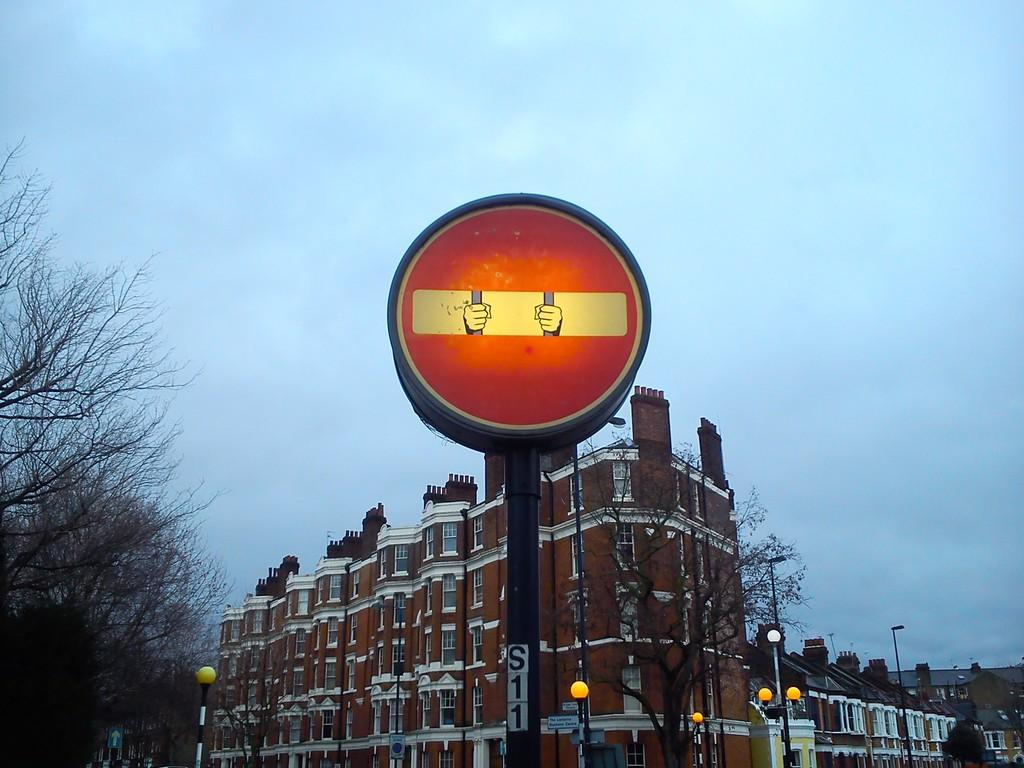What is attached to the pole in the image? There is a board attached to a pole in the image. What can be seen in the distance behind the pole and board? Buildings are visible in the background of the image. What type of lighting is present in the background of the image? Street lights are present in the background of the image. Where are the trees located in the image? The trees are in the left corner of the image. What hobbies are being practiced at the airport in the image? There is no airport present in the image, and therefore no hobbies being practiced. 